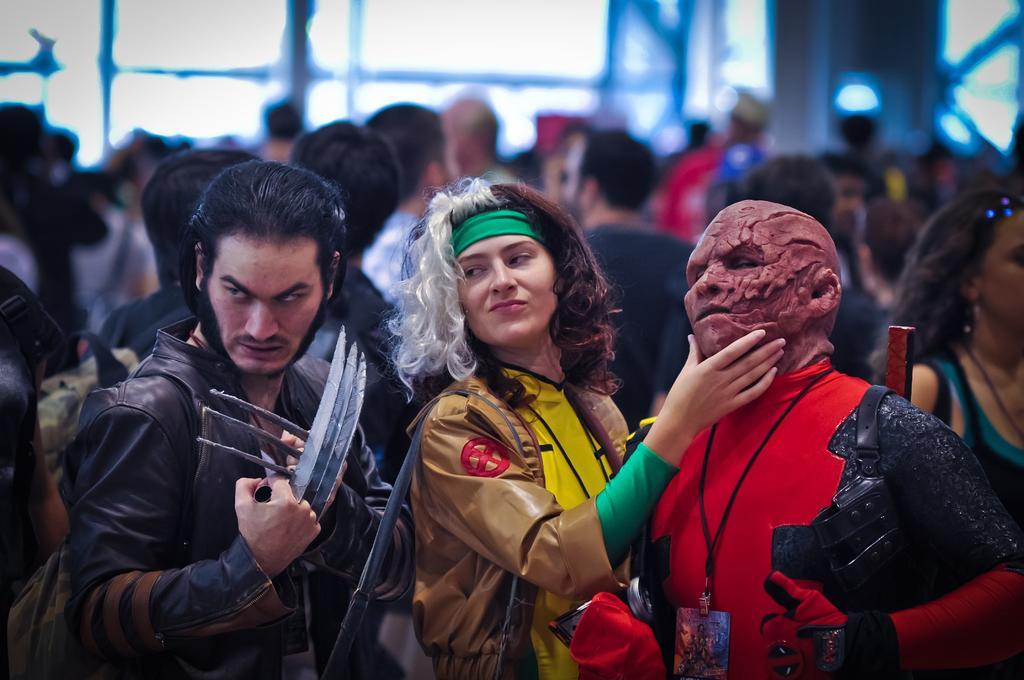Please provide a concise description of this image. In the center of the image we can see two people are standing and wearing costume. On the left side of the image we can see a man is standing and wearing jacket and holding an object. In the background of the image we can see a group of people are standing. At the top of the image we can see the wall, light and glass wall. 